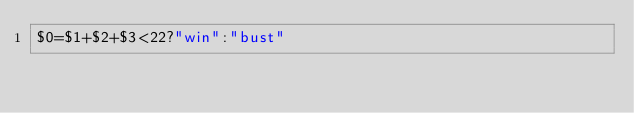Convert code to text. <code><loc_0><loc_0><loc_500><loc_500><_Awk_>$0=$1+$2+$3<22?"win":"bust"</code> 